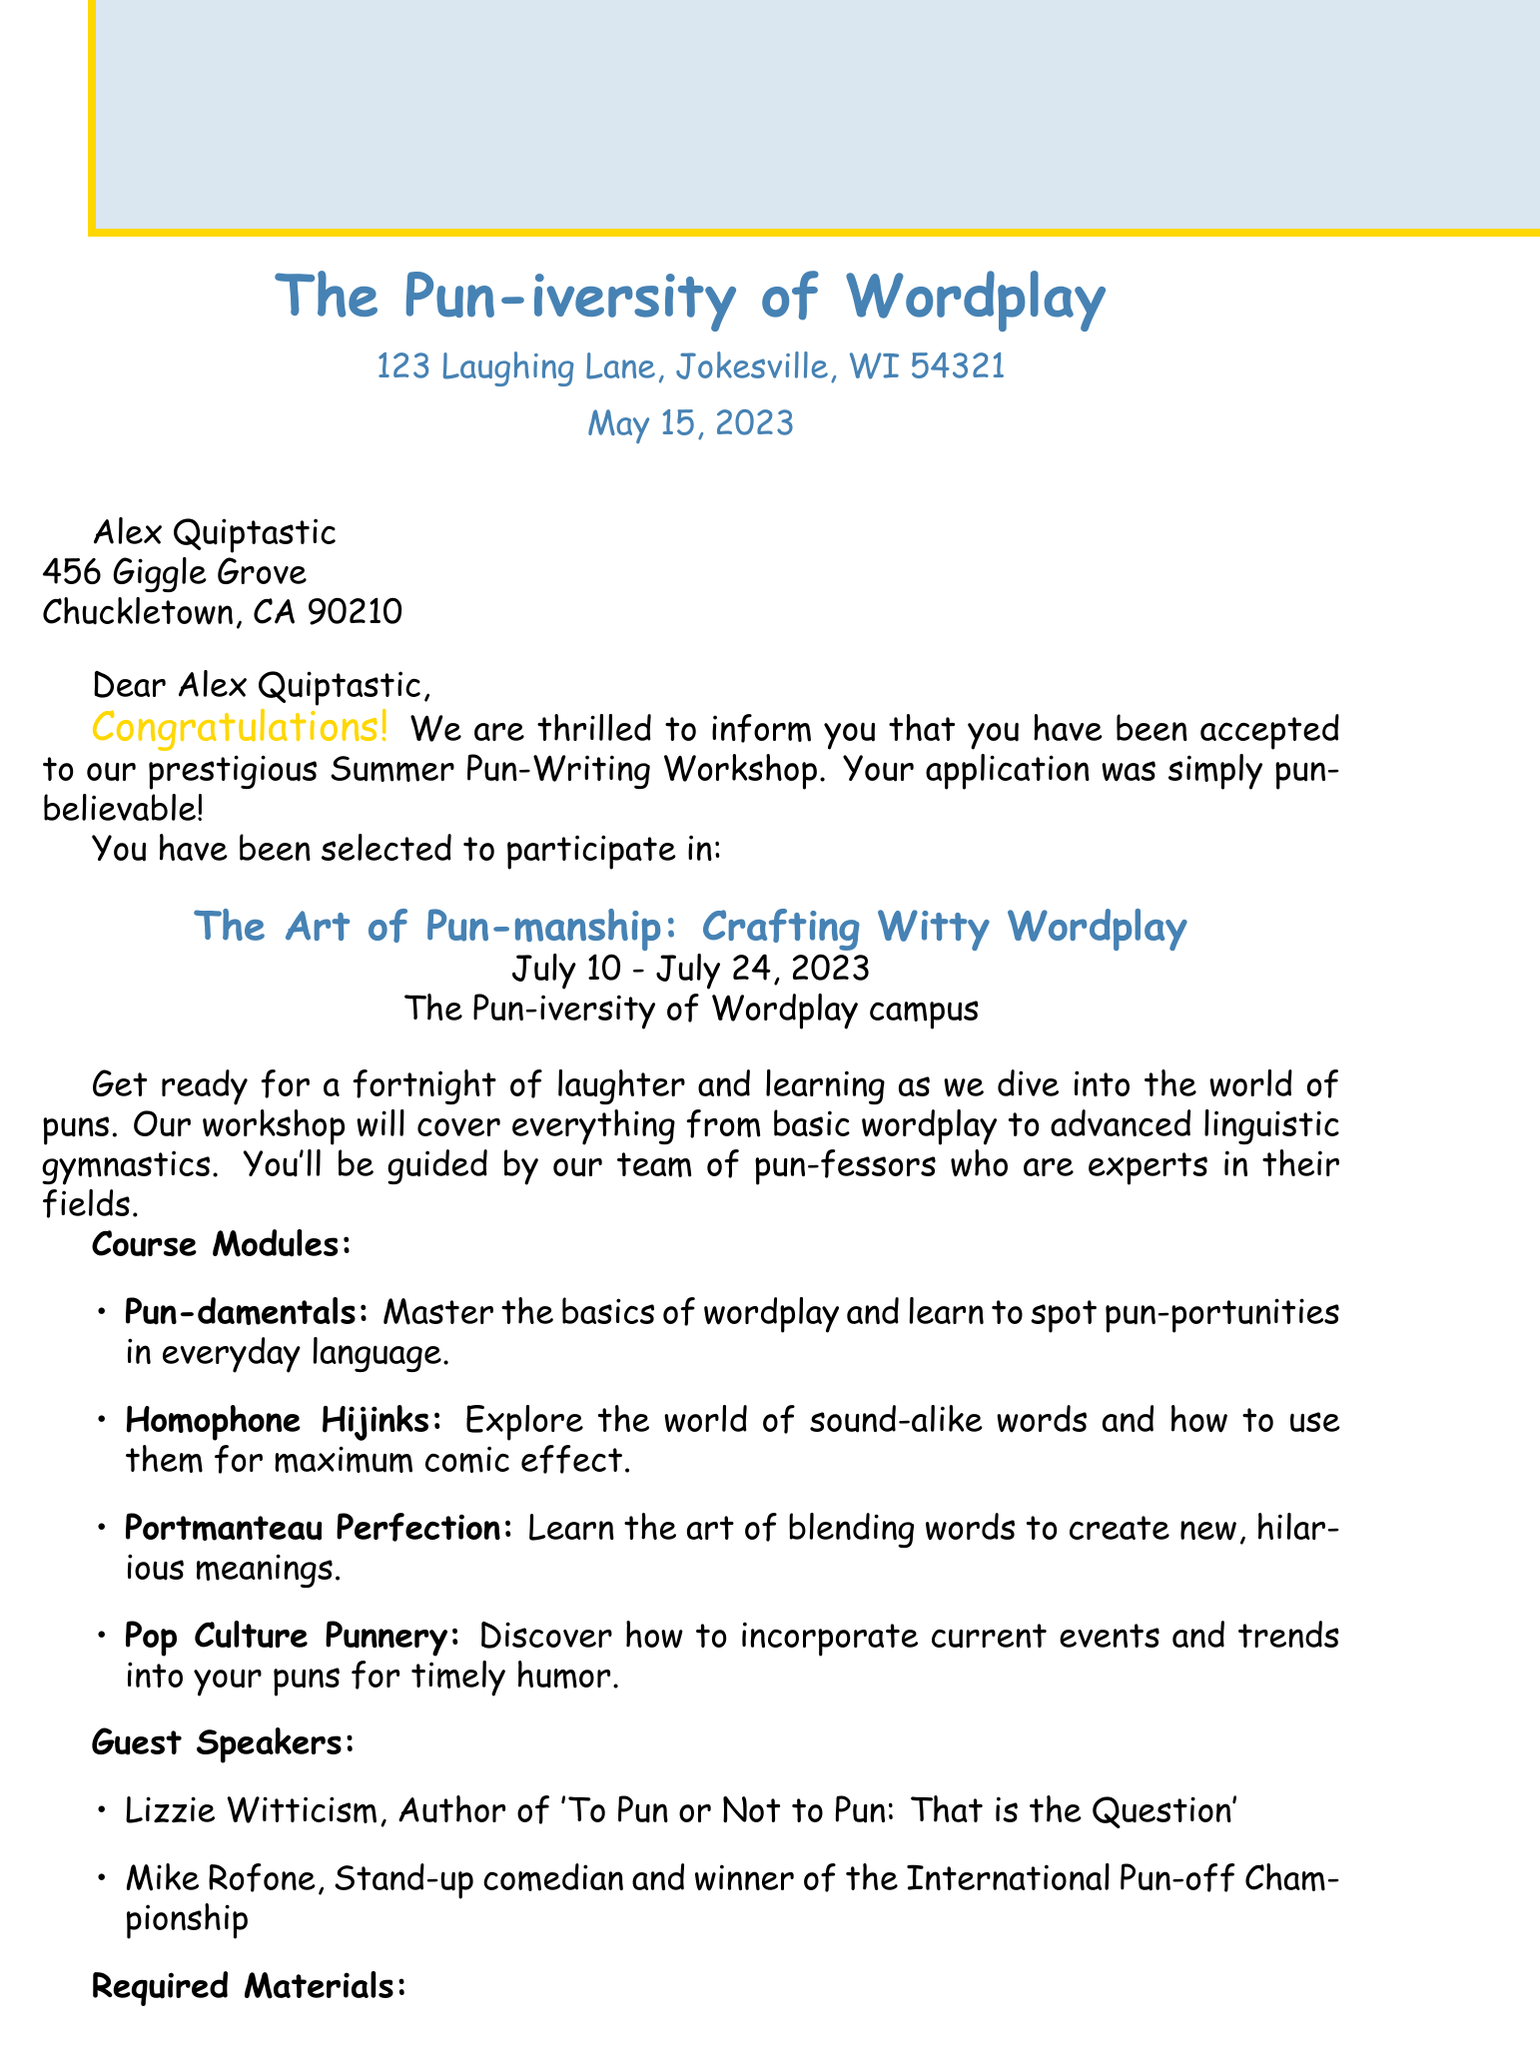What institution sent the acceptance letter? The institution that sent the letter is mentioned at the top of the document.
Answer: The Pun-iversity of Wordplay What is the date of the acceptance letter? The letter includes the date on which it was written, located in the header.
Answer: May 15, 2023 Who is the student receiving the acceptance? The name of the student is clearly stated in the letter.
Answer: Alex Quiptastic When does the workshop take place? The dates for the workshop are provided in the workshop details section.
Answer: July 10 - July 24, 2023 What is the title of the workshop? The name of the workshop is found in a bold center-aligned format in the document.
Answer: The Art of Pun-manship: Crafting Witty Wordplay Which module focuses on blending words? The course modules describe various topics, including one focused on blending words.
Answer: Portmanteau Perfection What will participants receive as provided materials? The section lists items that will be provided to participants during the workshop.
Answer: Pun-tastic t-shirt Who is one of the guest speakers? The guest speakers are listed in their section, including their names and credentials.
Answer: Lizzie Witticism What is the sentiment conveyed in the closing remarks? The closing remarks express a positive outlook for the upcoming workshop experience in a punny way.
Answer: en-light-pun-ing What is the signature title of the letter? The title of the person who signed the letter is stated towards the end.
Answer: Dean of Comedic Arts 